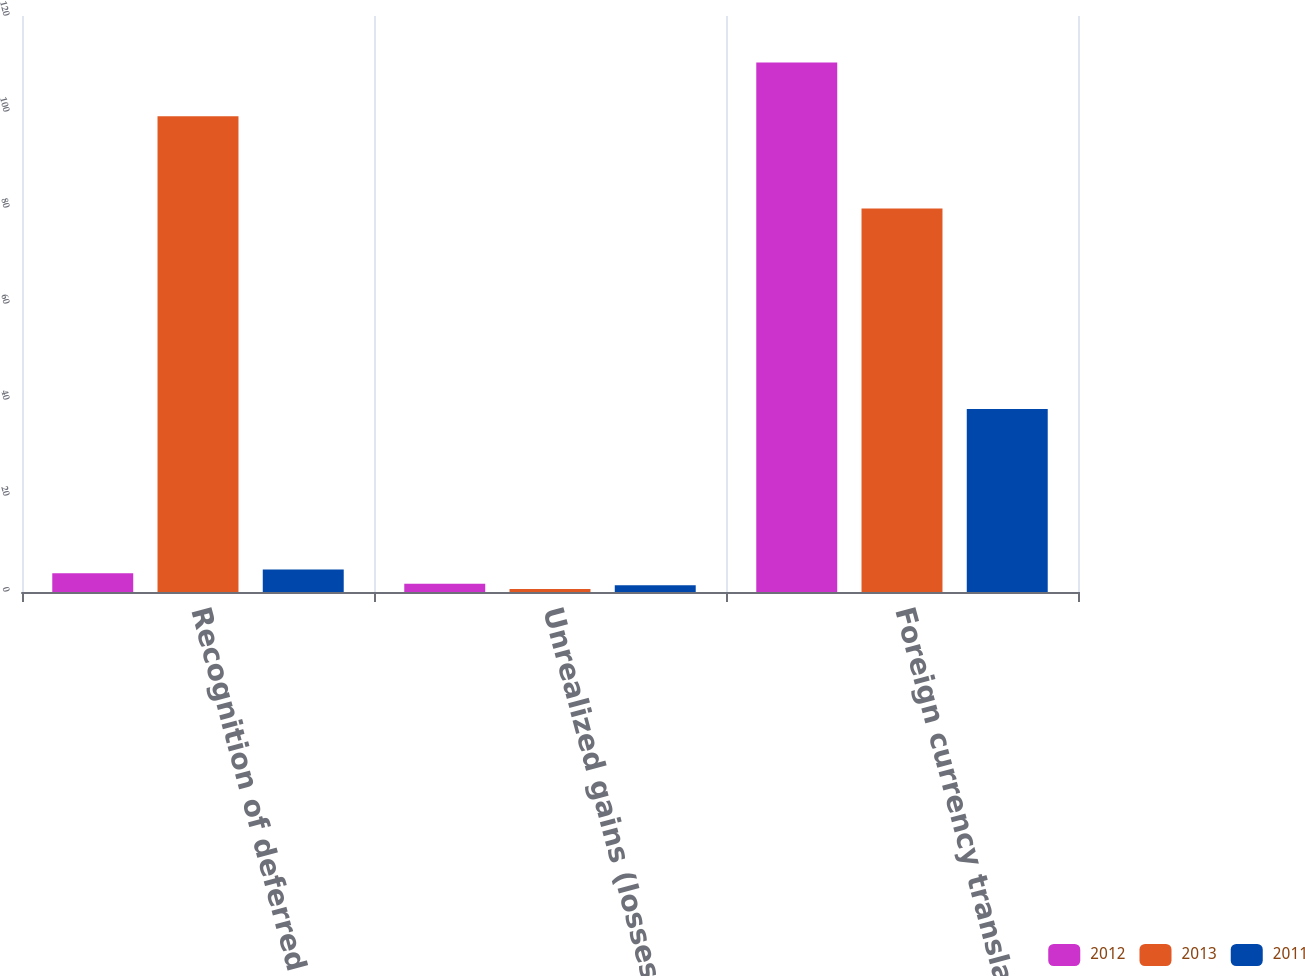<chart> <loc_0><loc_0><loc_500><loc_500><stacked_bar_chart><ecel><fcel>Recognition of deferred<fcel>Unrealized gains (losses) on<fcel>Foreign currency translation<nl><fcel>2012<fcel>3.9<fcel>1.7<fcel>110.3<nl><fcel>2013<fcel>99.1<fcel>0.6<fcel>79.9<nl><fcel>2011<fcel>4.7<fcel>1.4<fcel>38.1<nl></chart> 